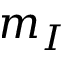Convert formula to latex. <formula><loc_0><loc_0><loc_500><loc_500>m _ { I }</formula> 